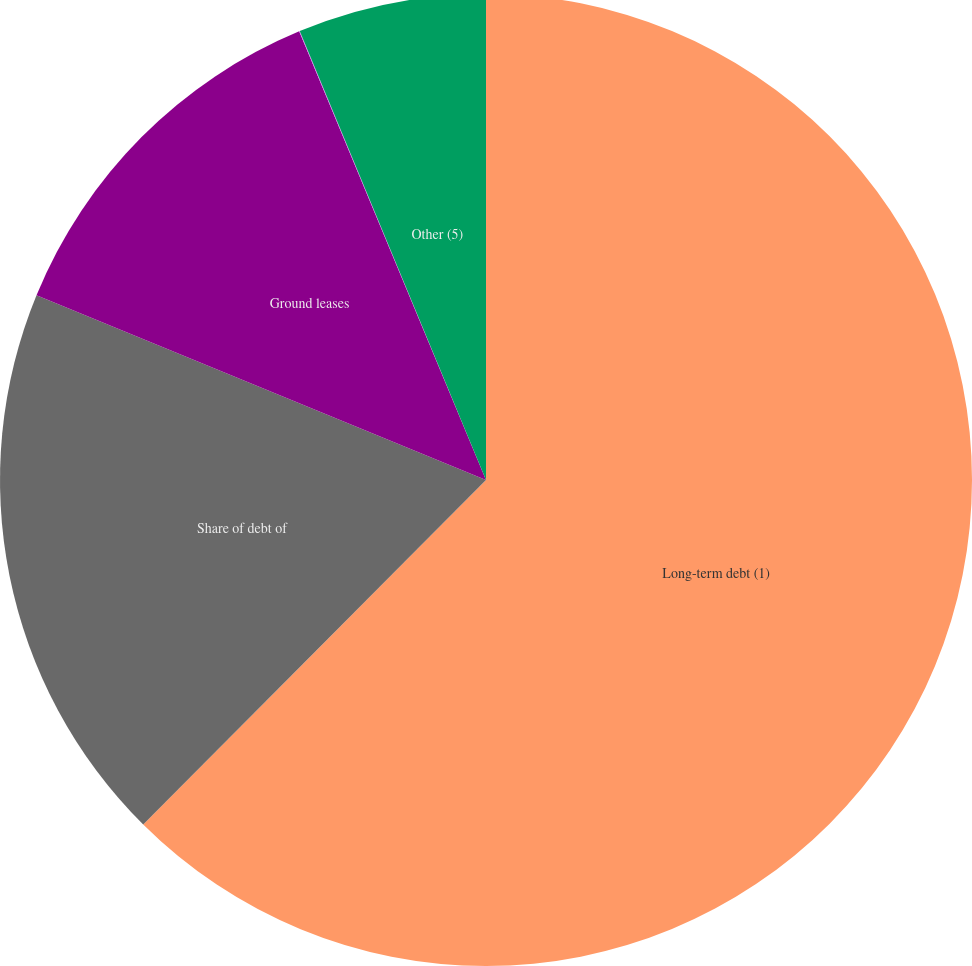<chart> <loc_0><loc_0><loc_500><loc_500><pie_chart><fcel>Long-term debt (1)<fcel>Share of debt of<fcel>Ground leases<fcel>Operating leases<fcel>Other (5)<nl><fcel>62.46%<fcel>18.75%<fcel>12.51%<fcel>0.02%<fcel>6.26%<nl></chart> 